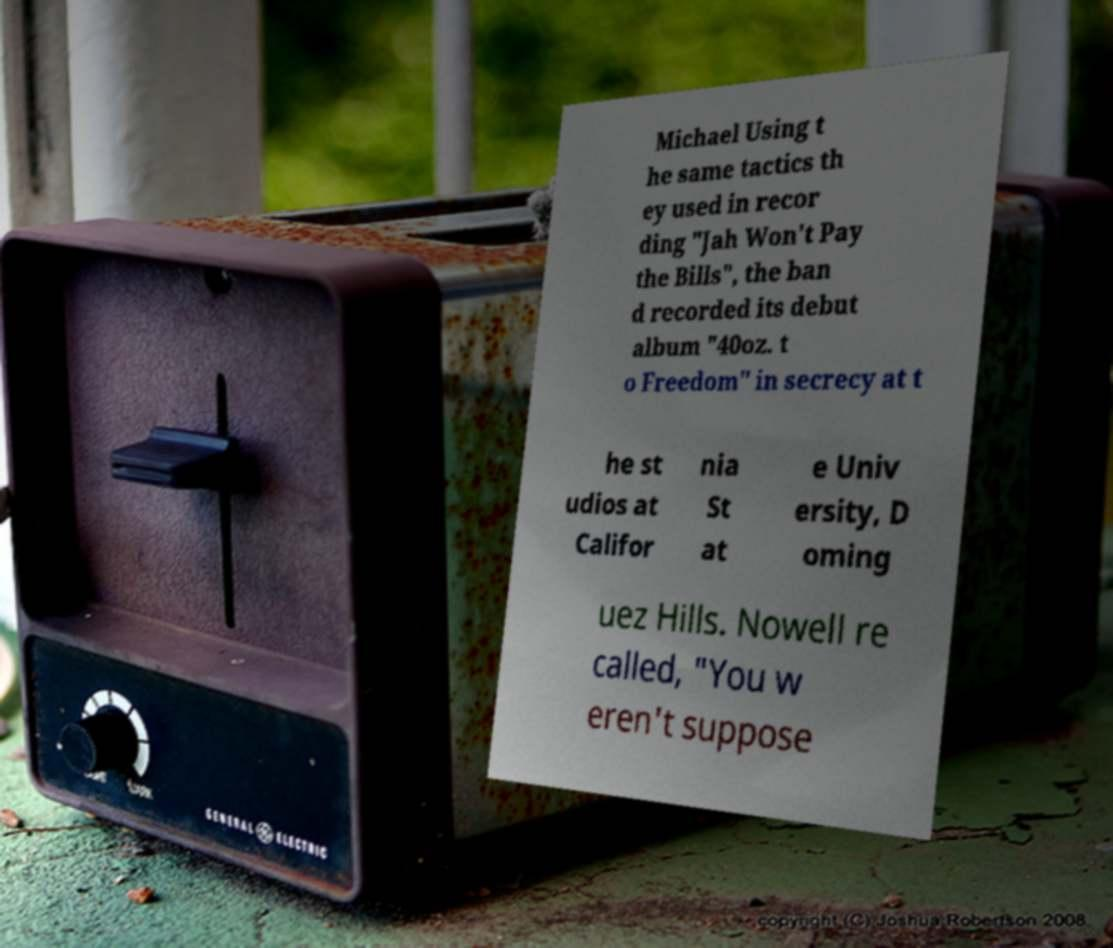Can you read and provide the text displayed in the image?This photo seems to have some interesting text. Can you extract and type it out for me? Michael Using t he same tactics th ey used in recor ding "Jah Won't Pay the Bills", the ban d recorded its debut album "40oz. t o Freedom" in secrecy at t he st udios at Califor nia St at e Univ ersity, D oming uez Hills. Nowell re called, "You w eren't suppose 